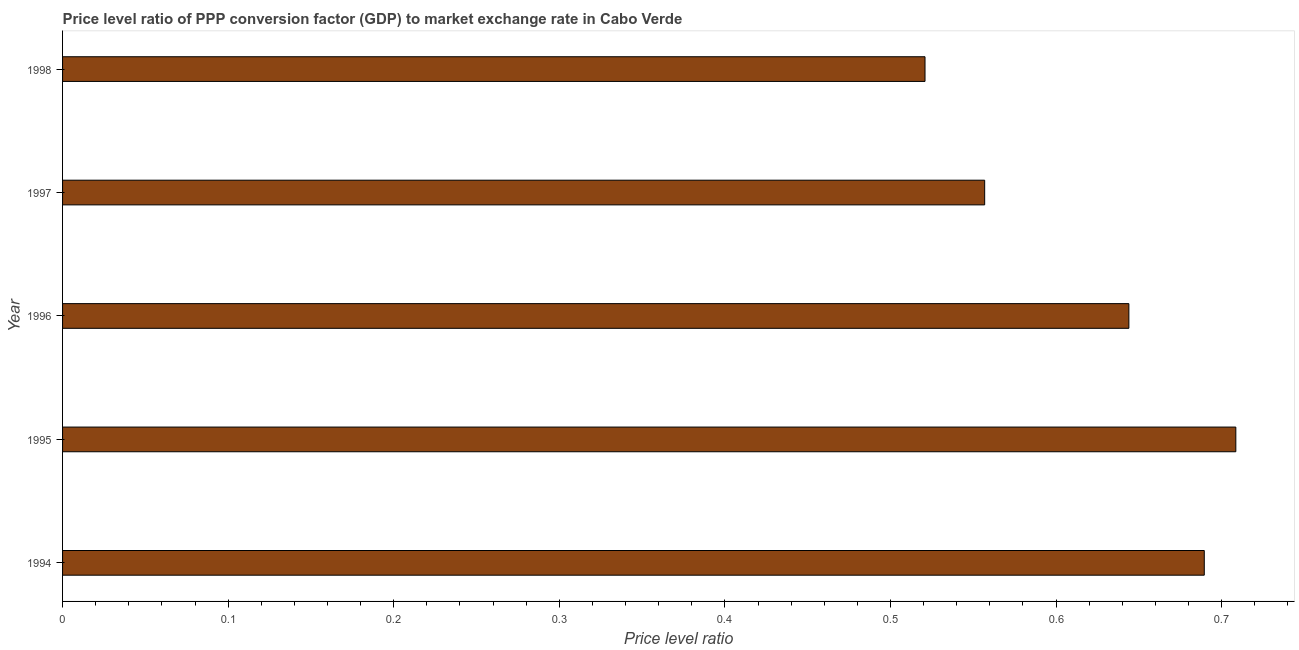Does the graph contain any zero values?
Provide a succinct answer. No. What is the title of the graph?
Keep it short and to the point. Price level ratio of PPP conversion factor (GDP) to market exchange rate in Cabo Verde. What is the label or title of the X-axis?
Your answer should be very brief. Price level ratio. What is the price level ratio in 1994?
Provide a succinct answer. 0.69. Across all years, what is the maximum price level ratio?
Offer a very short reply. 0.71. Across all years, what is the minimum price level ratio?
Make the answer very short. 0.52. What is the sum of the price level ratio?
Make the answer very short. 3.12. What is the difference between the price level ratio in 1994 and 1996?
Your response must be concise. 0.05. What is the average price level ratio per year?
Give a very brief answer. 0.62. What is the median price level ratio?
Keep it short and to the point. 0.64. In how many years, is the price level ratio greater than 0.14 ?
Offer a very short reply. 5. What is the ratio of the price level ratio in 1994 to that in 1995?
Provide a short and direct response. 0.97. Is the price level ratio in 1995 less than that in 1997?
Your response must be concise. No. Is the difference between the price level ratio in 1996 and 1998 greater than the difference between any two years?
Keep it short and to the point. No. What is the difference between the highest and the second highest price level ratio?
Give a very brief answer. 0.02. What is the difference between the highest and the lowest price level ratio?
Give a very brief answer. 0.19. How many years are there in the graph?
Offer a terse response. 5. What is the difference between two consecutive major ticks on the X-axis?
Offer a very short reply. 0.1. Are the values on the major ticks of X-axis written in scientific E-notation?
Offer a terse response. No. What is the Price level ratio in 1994?
Your answer should be very brief. 0.69. What is the Price level ratio of 1995?
Ensure brevity in your answer.  0.71. What is the Price level ratio of 1996?
Give a very brief answer. 0.64. What is the Price level ratio of 1997?
Ensure brevity in your answer.  0.56. What is the Price level ratio of 1998?
Provide a short and direct response. 0.52. What is the difference between the Price level ratio in 1994 and 1995?
Give a very brief answer. -0.02. What is the difference between the Price level ratio in 1994 and 1996?
Provide a succinct answer. 0.05. What is the difference between the Price level ratio in 1994 and 1997?
Make the answer very short. 0.13. What is the difference between the Price level ratio in 1994 and 1998?
Make the answer very short. 0.17. What is the difference between the Price level ratio in 1995 and 1996?
Your response must be concise. 0.06. What is the difference between the Price level ratio in 1995 and 1997?
Give a very brief answer. 0.15. What is the difference between the Price level ratio in 1995 and 1998?
Your response must be concise. 0.19. What is the difference between the Price level ratio in 1996 and 1997?
Make the answer very short. 0.09. What is the difference between the Price level ratio in 1996 and 1998?
Make the answer very short. 0.12. What is the difference between the Price level ratio in 1997 and 1998?
Your answer should be compact. 0.04. What is the ratio of the Price level ratio in 1994 to that in 1995?
Keep it short and to the point. 0.97. What is the ratio of the Price level ratio in 1994 to that in 1996?
Give a very brief answer. 1.07. What is the ratio of the Price level ratio in 1994 to that in 1997?
Give a very brief answer. 1.24. What is the ratio of the Price level ratio in 1994 to that in 1998?
Your response must be concise. 1.32. What is the ratio of the Price level ratio in 1995 to that in 1996?
Keep it short and to the point. 1.1. What is the ratio of the Price level ratio in 1995 to that in 1997?
Ensure brevity in your answer.  1.27. What is the ratio of the Price level ratio in 1995 to that in 1998?
Make the answer very short. 1.36. What is the ratio of the Price level ratio in 1996 to that in 1997?
Provide a short and direct response. 1.16. What is the ratio of the Price level ratio in 1996 to that in 1998?
Your answer should be very brief. 1.24. What is the ratio of the Price level ratio in 1997 to that in 1998?
Your answer should be very brief. 1.07. 